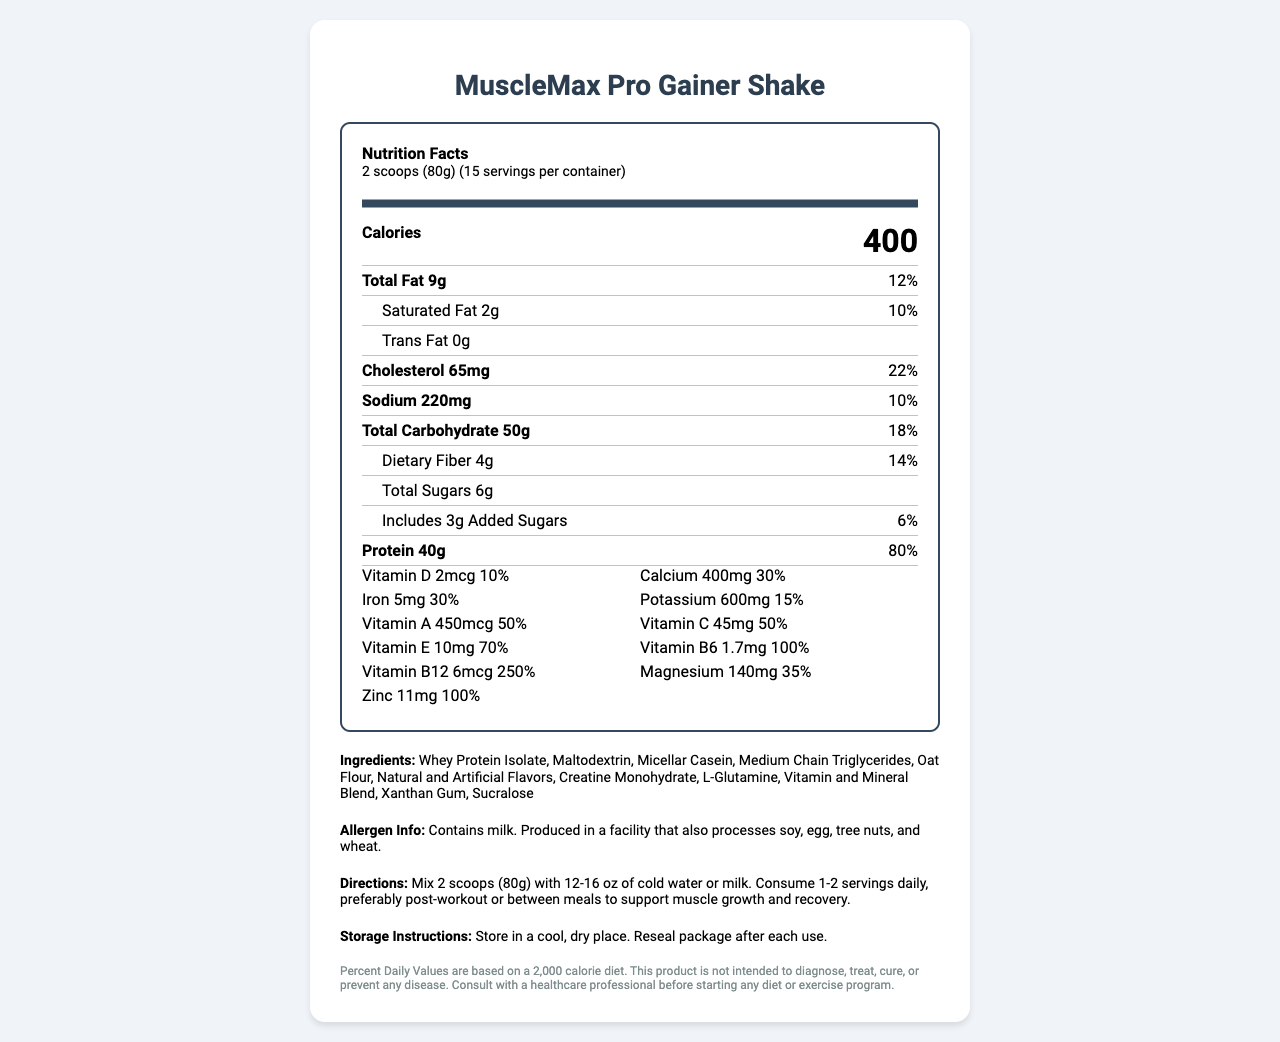What is the serving size of the MuscleMax Pro Gainer Shake? The serving size is clearly stated as "2 scoops (80g)" on the document.
Answer: 2 scoops (80g) How many calories are in one serving of the MuscleMax Pro Gainer Shake? The document mentions "Calories 400" under nutrition facts.
Answer: 400 calories What is the protein content per serving? The document lists "Protein 40g" with its daily value next to it.
Answer: 40g What percent of the daily value of saturated fat is in one serving of the shake? The document specifies "Saturated Fat 2g" and lists "10%" as the daily value percentage.
Answer: 10% How much dietary fiber is in the shake? The document lists "Dietary Fiber 4g" under the total carbohydrate section.
Answer: 4g How much Vitamin C does the shake provide per serving? The section under vitamins lists "Vitamin C 45mg" along with its daily percentage.
Answer: 45mg How many servings are there per container of MuscleMax Pro Gainer Shake? A. 10 B. 12 C. 15 D. 20 The document clearly states there are 15 servings per container.
Answer: C What is the main source of protein in the shake based on ingredients list? A. Soy Protein B. Whey Protein Isolate C. Pea Protein D. Egg Whites The ingredients list starts with "Whey Protein Isolate," indicating it is the primary source.
Answer: B Does the shake contain any trans fat? The section under fats states "Trans Fat 0g," indicating there is no trans fat.
Answer: No Is the MuscleMax Pro Gainer Shake safe for someone with a tree nut allergy? The allergen info states the product is produced in a facility that processes tree nuts.
Answer: No What are the directions for consuming the MuscleMax Pro Gainer Shake? The directions section provides detailed instructions on how to prepare and consume the shake for best results.
Answer: Mix 2 scoops (80g) with 12-16 oz of cold water or milk. Consume 1-2 servings daily, preferably post-workout or between meals to support muscle growth and recovery. Provide a summary of the MuscleMax Pro Gainer Shake Nutrition Facts. The document details the nutritional content, ingredients, directions, and other key information about the MuscleMax Pro Gainer Shake.
Answer: The MuscleMax Pro Gainer Shake is a meal replacement shake designed for muscle gain. Each serving is 2 scoops (80g), providing 400 calories, 40g of protein, 50g of carbohydrates, and 9g of total fat. The shake also contains various vitamins and minerals, such as Vitamin C, Calcium, Iron, and Vitamin B12. It is made from ingredients including Whey Protein Isolate, Micellar Casein, and Creatine Monohydrate. The product should be mixed with water or milk and consumed post-workout or between meals. Can the shake be used as a primary treatment for muscle diseases? The document includes disclaimers stating that the product is not intended to diagnose, treat, cure, or prevent any disease.
Answer: Cannot be determined 